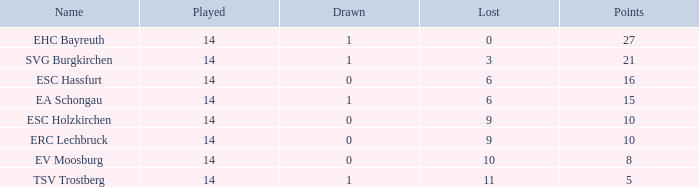What's the lost when there were more than 16 points and had a drawn less than 1? None. 